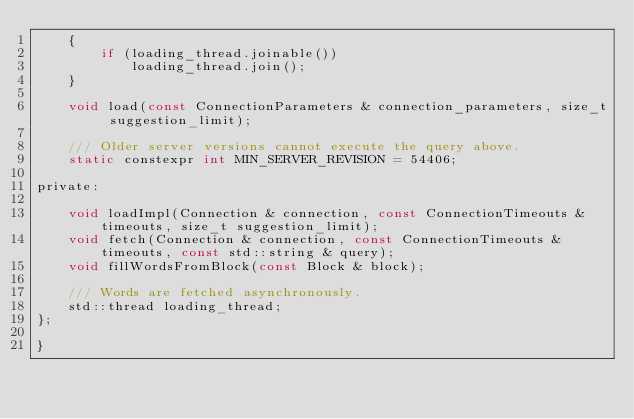<code> <loc_0><loc_0><loc_500><loc_500><_C_>    {
        if (loading_thread.joinable())
            loading_thread.join();
    }

    void load(const ConnectionParameters & connection_parameters, size_t suggestion_limit);

    /// Older server versions cannot execute the query above.
    static constexpr int MIN_SERVER_REVISION = 54406;

private:

    void loadImpl(Connection & connection, const ConnectionTimeouts & timeouts, size_t suggestion_limit);
    void fetch(Connection & connection, const ConnectionTimeouts & timeouts, const std::string & query);
    void fillWordsFromBlock(const Block & block);

    /// Words are fetched asynchronously.
    std::thread loading_thread;
};

}
</code> 